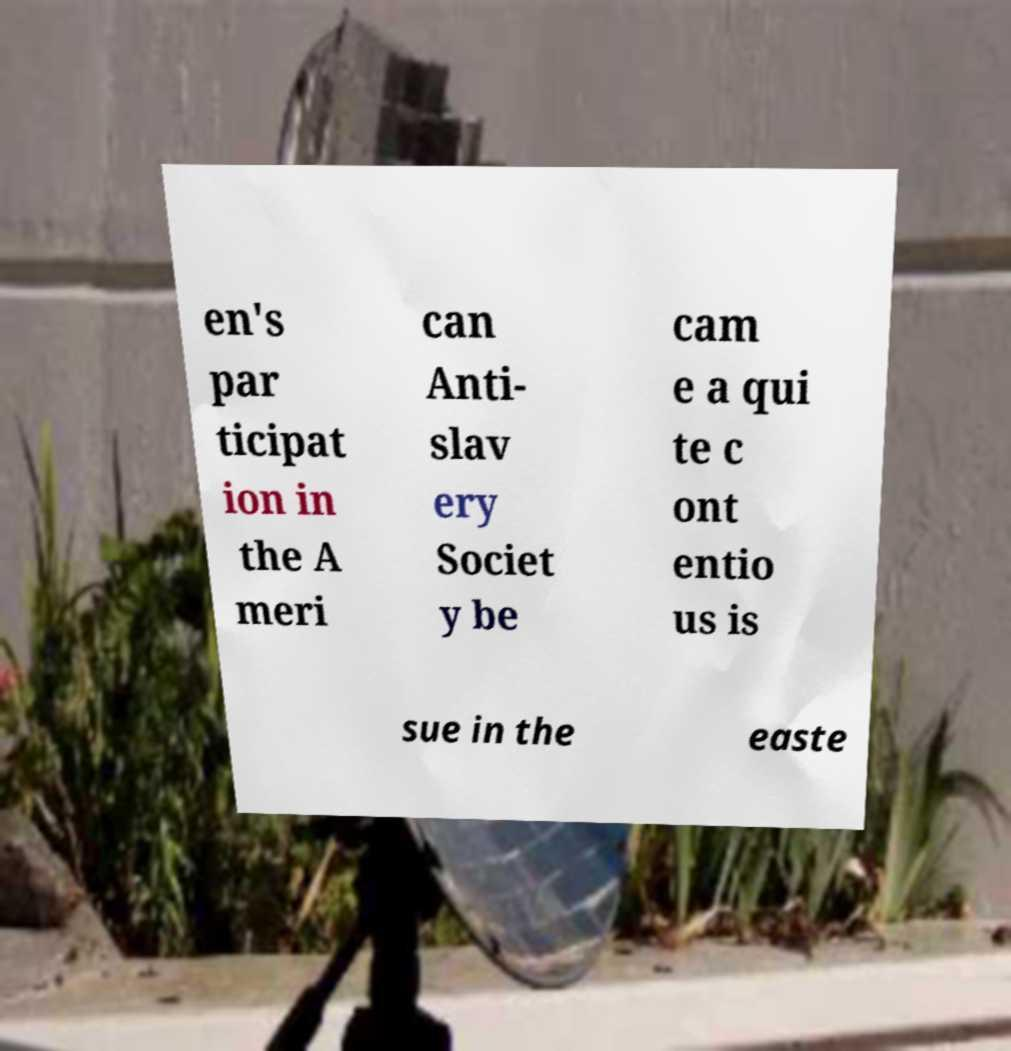For documentation purposes, I need the text within this image transcribed. Could you provide that? en's par ticipat ion in the A meri can Anti- slav ery Societ y be cam e a qui te c ont entio us is sue in the easte 